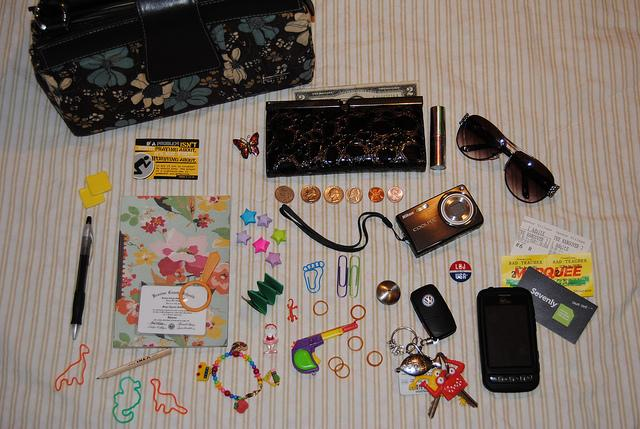What brand of car does this person drive?

Choices:
A) volkswagen
B) honda
C) toyota
D) ford volkswagen 